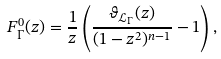Convert formula to latex. <formula><loc_0><loc_0><loc_500><loc_500>F _ { \Gamma } ^ { 0 } ( z ) = \frac { 1 } { z } \left ( \frac { \vartheta _ { \mathcal { L } _ { \Gamma } } ( z ) } { ( 1 - z ^ { 2 } ) ^ { n - 1 } } - 1 \right ) ,</formula> 